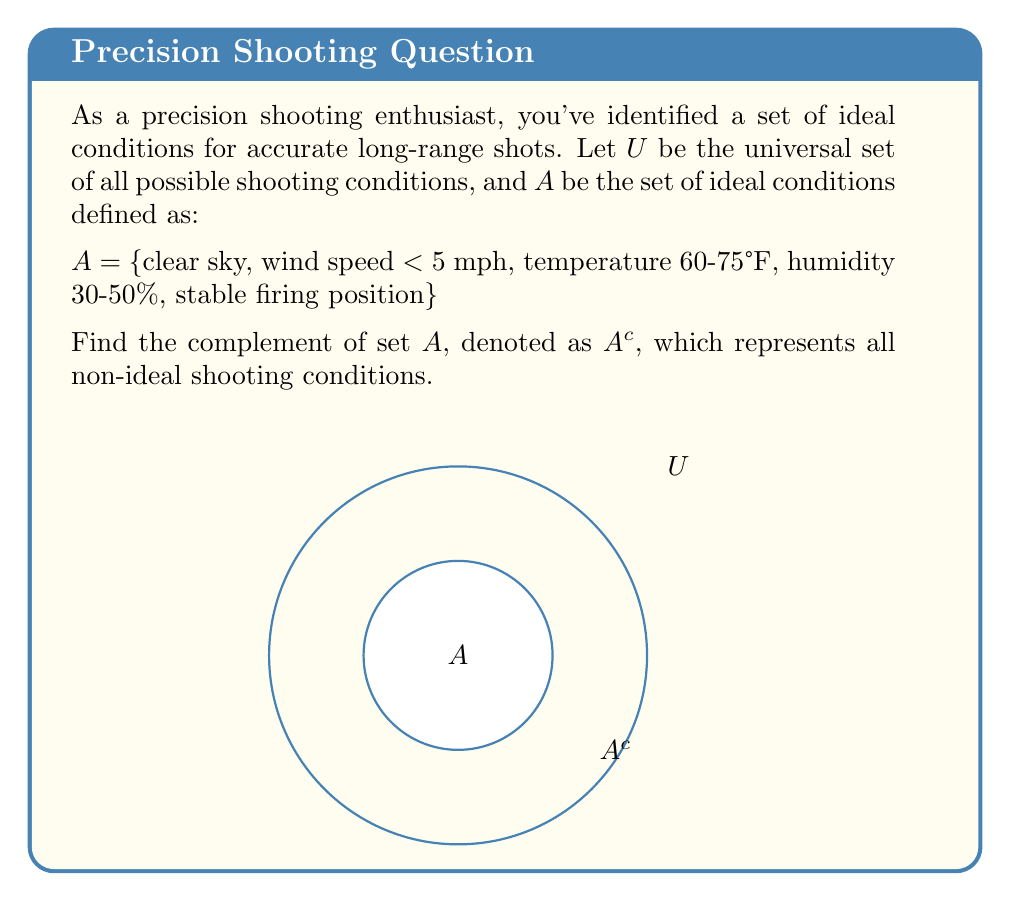Show me your answer to this math problem. To find the complement of set $A$, we need to identify all elements in the universal set $U$ that are not in set $A$. Let's approach this step-by-step:

1) First, let's consider each condition in set $A$ and its opposite:
   - Clear sky → Cloudy or overcast sky
   - Wind speed < 5 mph → Wind speed ≥ 5 mph
   - Temperature 60-75°F → Temperature < 60°F or > 75°F
   - Humidity 30-50% → Humidity < 30% or > 50%
   - Stable firing position → Unstable firing position

2) The complement set $A^c$ will include all these opposite conditions, as well as any other conditions not mentioned in set $A$.

3) Mathematically, we can express this as:

   $A^c = U \setminus A$

   Where $\setminus$ denotes the set difference operation.

4) In set builder notation, we can write:

   $A^c = \{x \in U | x \notin A\}$

5) Therefore, $A^c$ includes all elements of $U$ that are not in $A$, which are all the non-ideal shooting conditions.
Answer: $A^c = \{$cloudy/overcast sky, wind speed ≥ 5 mph, temperature < 60°F or > 75°F, humidity < 30% or > 50%, unstable firing position, and all other non-ideal conditions$\}$ 